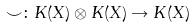<formula> <loc_0><loc_0><loc_500><loc_500>\smile \colon K ( X ) \otimes K ( X ) \rightarrow K ( X )</formula> 